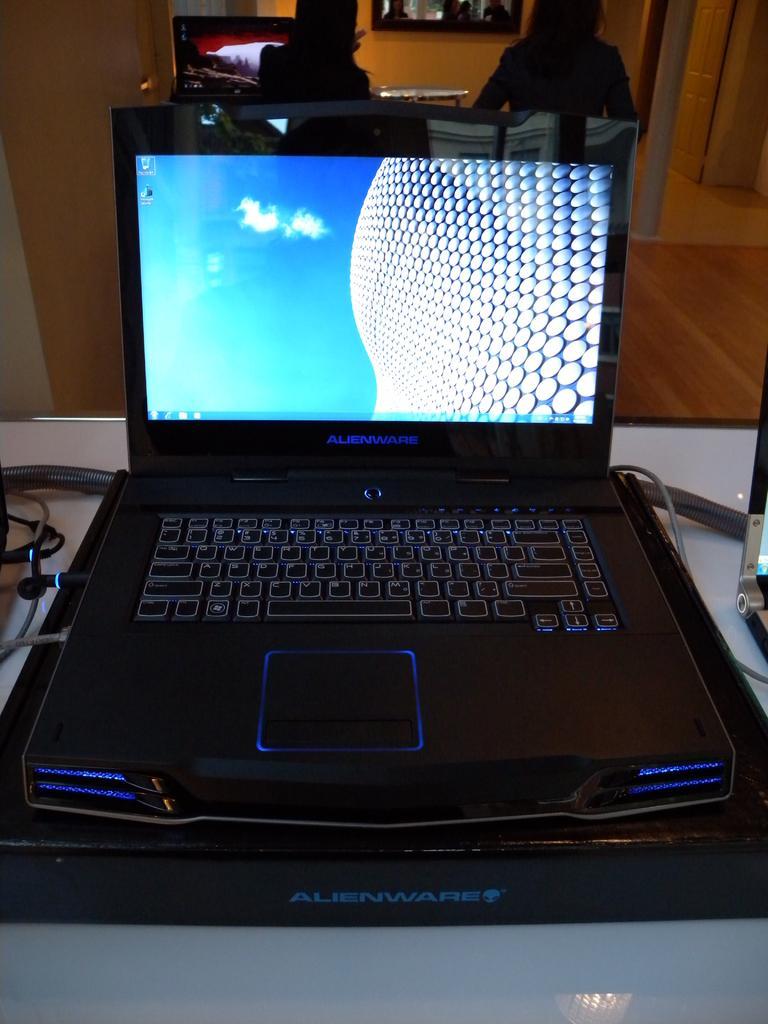<image>
Give a short and clear explanation of the subsequent image. The black laptop had the name Alienware on the front 